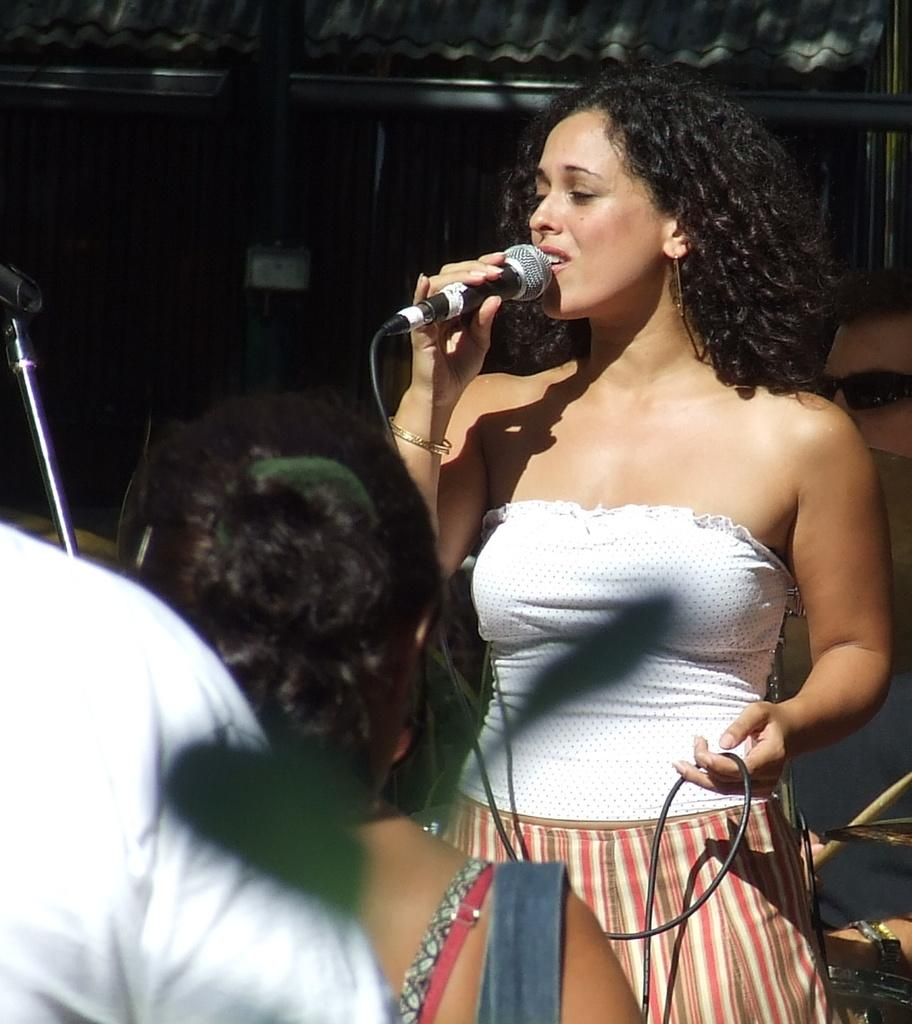What is the woman in the image doing? The woman is holding a mic and singing. What is the woman wearing? The woman is wearing a white t-shirt. Who else can be seen in the image? There is an audience in the image. What is in the distance in the image? There is a shed in the distance. What else can be seen related to music in the image? There is a musical plate in the image. Can you describe the man's appearance in the image? A man is wearing goggles. What type of caption is written on the bottom of the image? There is no caption written on the bottom of the image. What is the slope of the hill in the image? There is no hill or slope present in the image. 